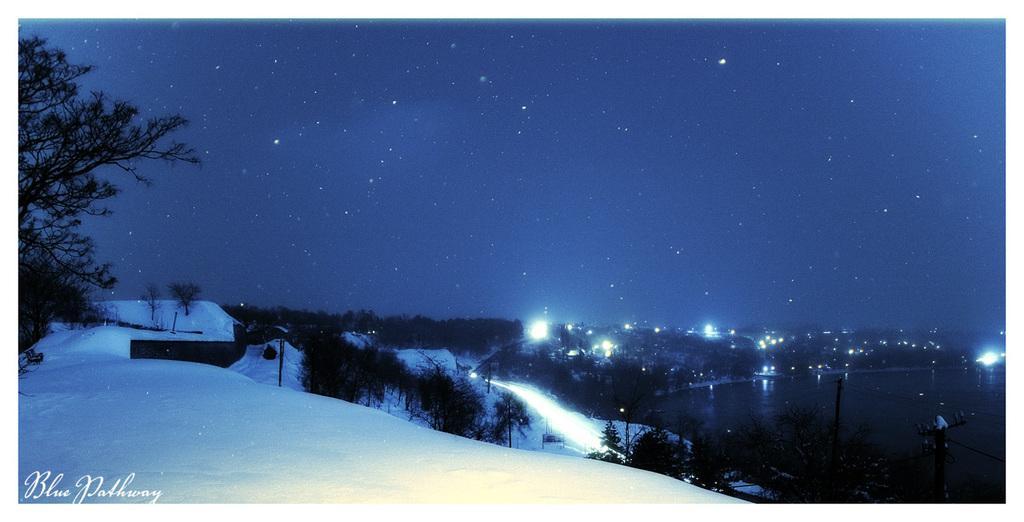Can you describe this image briefly? This image is taken outdoors. At the top of the image there is a sky with stars. At the bottom of the image there is a ground covered with snow. On the left side of the image there is a tree. In the middle of the image there are many trees and plants and there are a few lights. On the right side of the image there is a pond with water. 